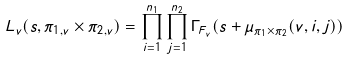<formula> <loc_0><loc_0><loc_500><loc_500>L _ { v } ( s , \pi _ { 1 , v } \times \pi _ { 2 , v } ) = \prod _ { i = 1 } ^ { n _ { 1 } } \prod _ { j = 1 } ^ { n _ { 2 } } \Gamma _ { F _ { v } } ( s + \mu _ { \pi _ { 1 } \times \pi _ { 2 } } ( v , i , j ) )</formula> 